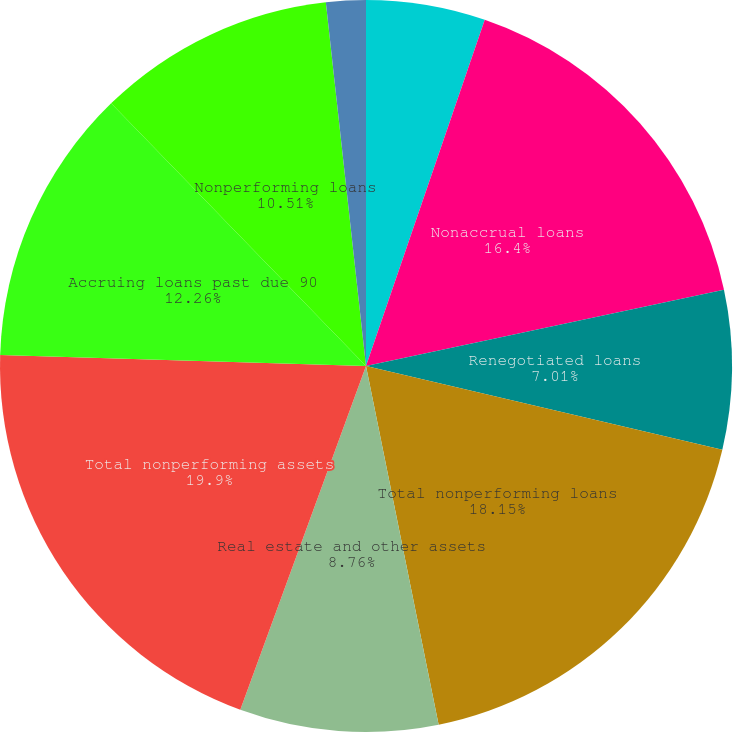Convert chart. <chart><loc_0><loc_0><loc_500><loc_500><pie_chart><fcel>December 31<fcel>Nonaccrual loans<fcel>Renegotiated loans<fcel>Total nonperforming loans<fcel>Real estate and other assets<fcel>Total nonperforming assets<fcel>Accruing loans past due 90<fcel>Nonperforming loans<fcel>Nonperforming loans to total<nl><fcel>5.26%<fcel>16.4%<fcel>7.01%<fcel>18.15%<fcel>8.76%<fcel>19.9%<fcel>12.26%<fcel>10.51%<fcel>1.75%<nl></chart> 